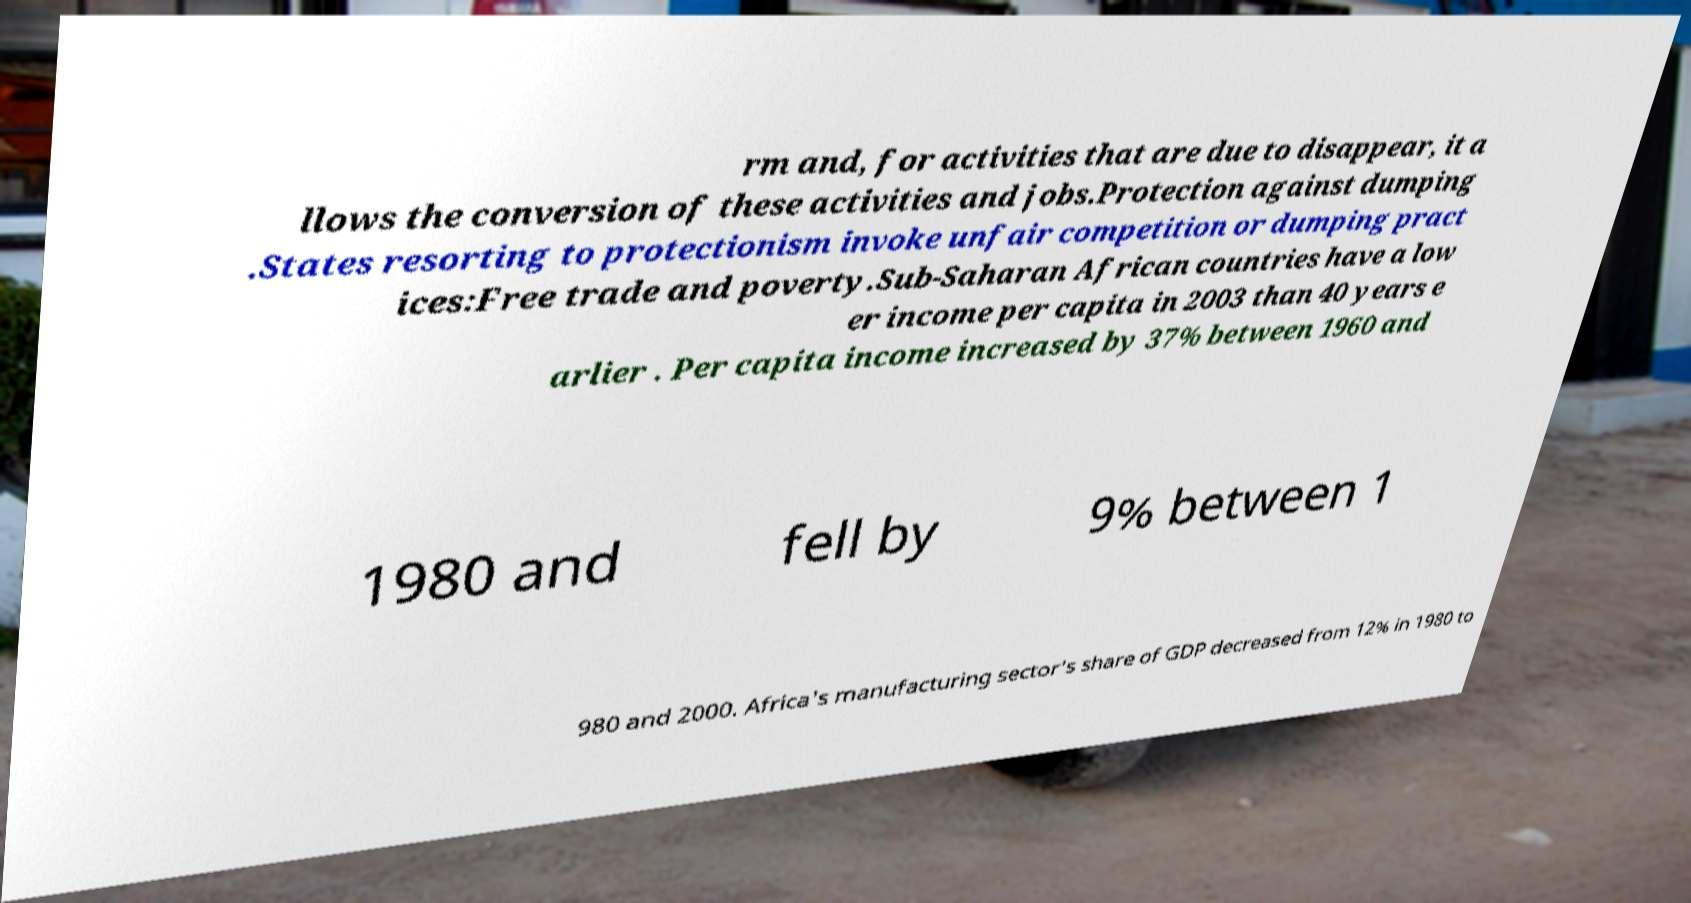There's text embedded in this image that I need extracted. Can you transcribe it verbatim? rm and, for activities that are due to disappear, it a llows the conversion of these activities and jobs.Protection against dumping .States resorting to protectionism invoke unfair competition or dumping pract ices:Free trade and poverty.Sub-Saharan African countries have a low er income per capita in 2003 than 40 years e arlier . Per capita income increased by 37% between 1960 and 1980 and fell by 9% between 1 980 and 2000. Africa's manufacturing sector's share of GDP decreased from 12% in 1980 to 